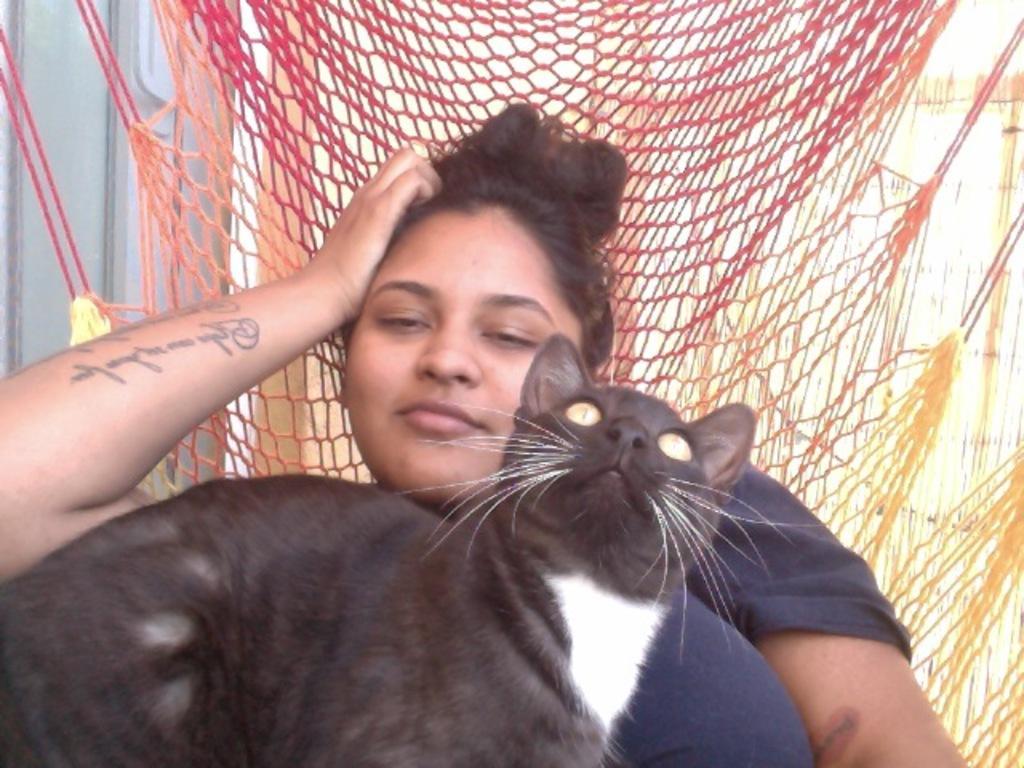Can you describe this image briefly? In the picture woman is sitting in a net chair a cat is sitting on the woman there is a wall behind the woman. 